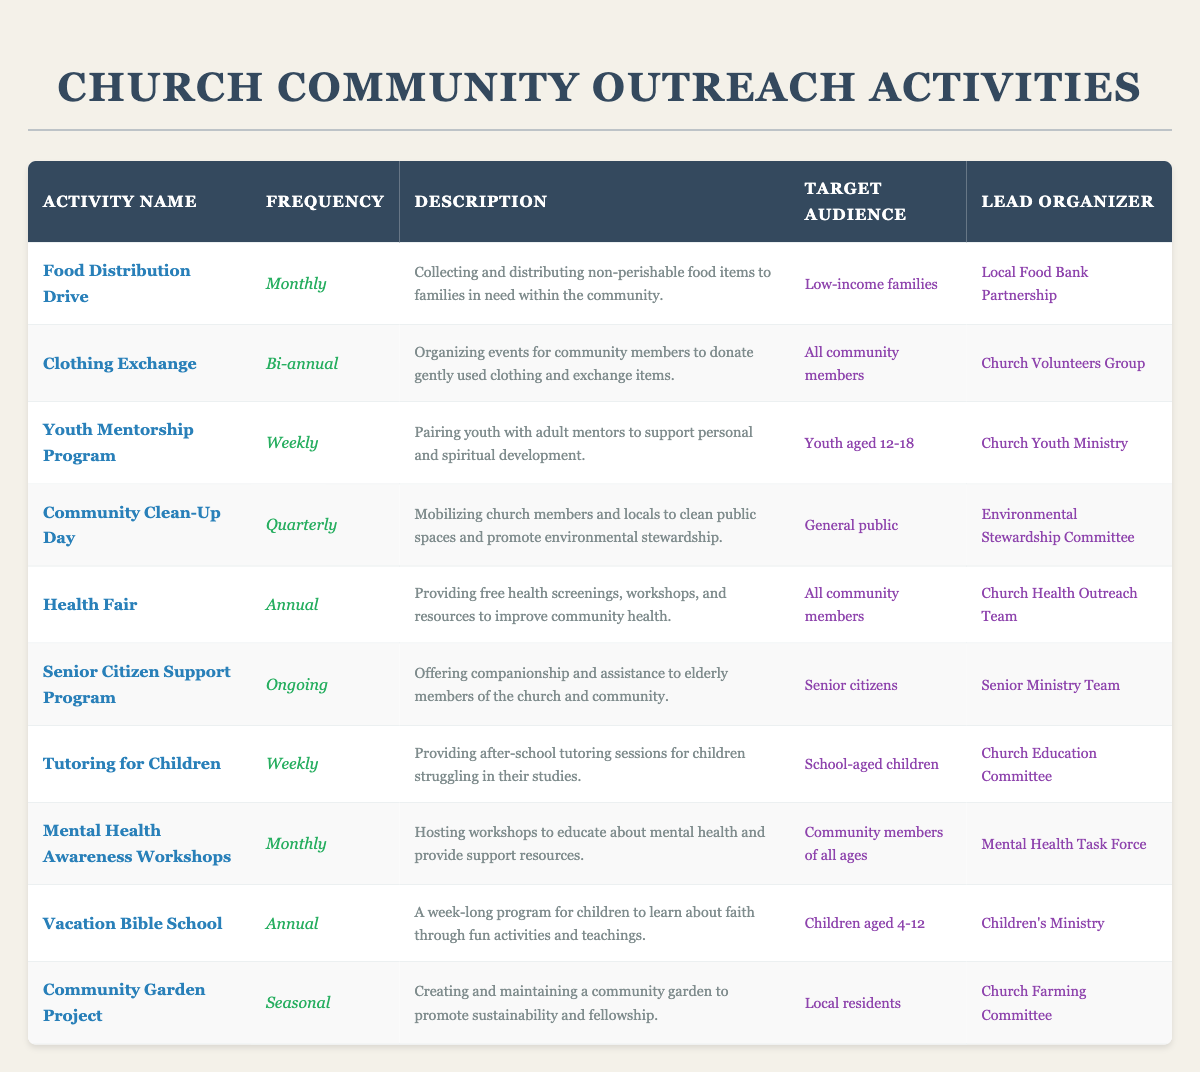What is the frequency of the Food Distribution Drive? The frequency for the Food Distribution Drive is listed in the table under the frequency column. It states "Monthly."
Answer: Monthly How many activities are organized on a weekly basis? There are two activities listed with a frequency of "Weekly": Youth Mentorship Program and Tutoring for Children.
Answer: 2 Is the Health Fair aimed at low-income families? The target audience for the Health Fair is specified in the table as "All community members," which does not limit it to low-income families.
Answer: No What is the lead organizer for the Clothing Exchange? Looking at the table, the lead organizer for the Clothing Exchange is mentioned as "Church Volunteers Group."
Answer: Church Volunteers Group Which activity has the target audience of senior citizens and is ongoing? Referring to the table, the activity that targets senior citizens and has an ongoing frequency is the Senior Citizen Support Program.
Answer: Senior Citizen Support Program How many activities occur more than once a month? The activities that occur more than once a month are: Youth Mentorship Program (weekly), Tutoring for Children (weekly), and Mental Health Awareness Workshops (monthly). Counting these gives us a total of four occurrences (2 weekly and 1 monthly).
Answer: 4 Which activity takes place annually and targets children aged 4-12? The Vacation Bible School is specified in the table as taking place annually and targeting children aged 4-12.
Answer: Vacation Bible School What is the purpose of the Community Clean-Up Day? According to the description in the table, the purpose of the Community Clean-Up Day is to mobilize church members and locals to clean public spaces and promote environmental stewardship.
Answer: To clean public spaces and promote environmental stewardship Are there any activities that provide free health screenings? Yes, the Health Fair is mentioned in the table as providing free health screenings.
Answer: Yes Which activity is led by the Church Youth Ministry? The table indicates that the Youth Mentorship Program is led by the Church Youth Ministry.
Answer: Youth Mentorship Program 